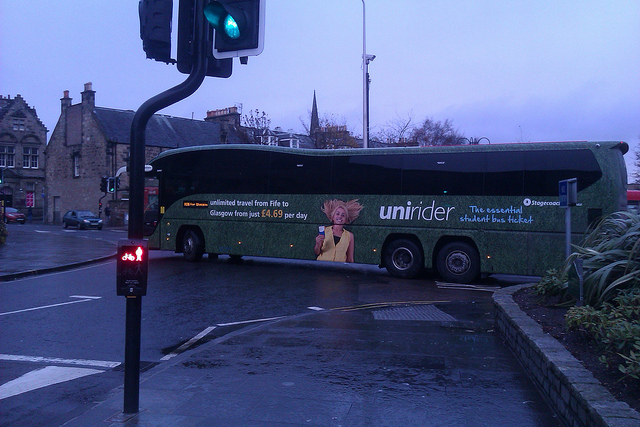Imagine the person on the bus advertisement. What might their story be? The person in the bus advertisement, with their distinctive spiky hair, might be a young student excited about new opportunities. Let's imagine they are an art student traveling between Fife and Glasgow, eager to take advantage of the unlimited travel pass to broaden their horizons, visit museums, and gather inspiration for their projects. What kind of art might this student be working on? This student could be working on a series of vibrant street art installations that reflect the cultural tapestry of Fife and Glasgow. They might be incorporating elements of their travels, such as urban landscapes, architecture, and everyday interactions within the city, into their art to tell compelling stories about urban life. Can you write a short poem about what the student sees during their travels? On cobbled streets where history sleeps,
In whispering winds, a city keeps,
Tall spires reach where skies enclose,
The bus’s hum, where life it flows.
From Fife to Glasgow, tales unfold,
In every corner, stories told,
Art etched in stone and hearts entwined,
Through windows, inspiration find. 